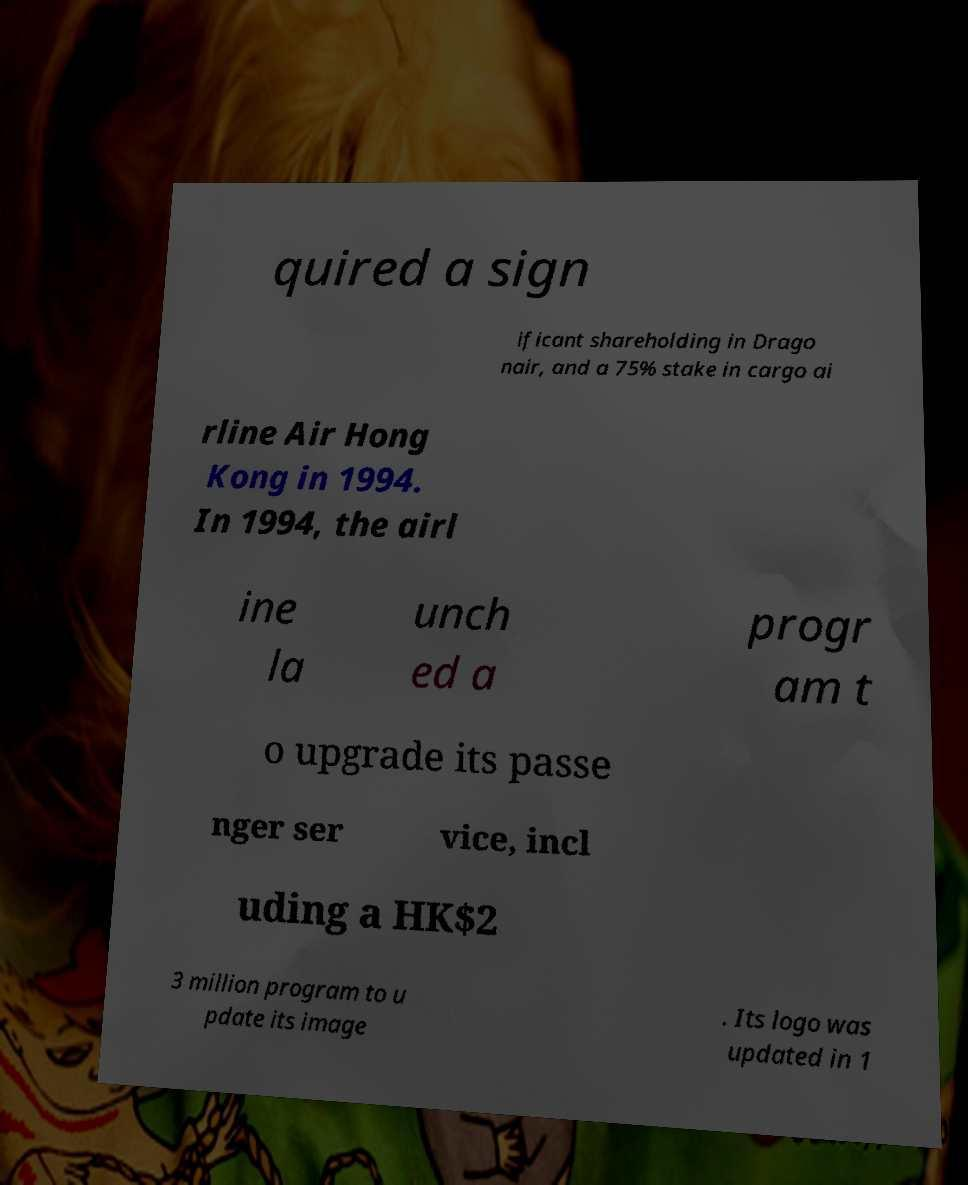Could you assist in decoding the text presented in this image and type it out clearly? quired a sign ificant shareholding in Drago nair, and a 75% stake in cargo ai rline Air Hong Kong in 1994. In 1994, the airl ine la unch ed a progr am t o upgrade its passe nger ser vice, incl uding a HK$2 3 million program to u pdate its image . Its logo was updated in 1 